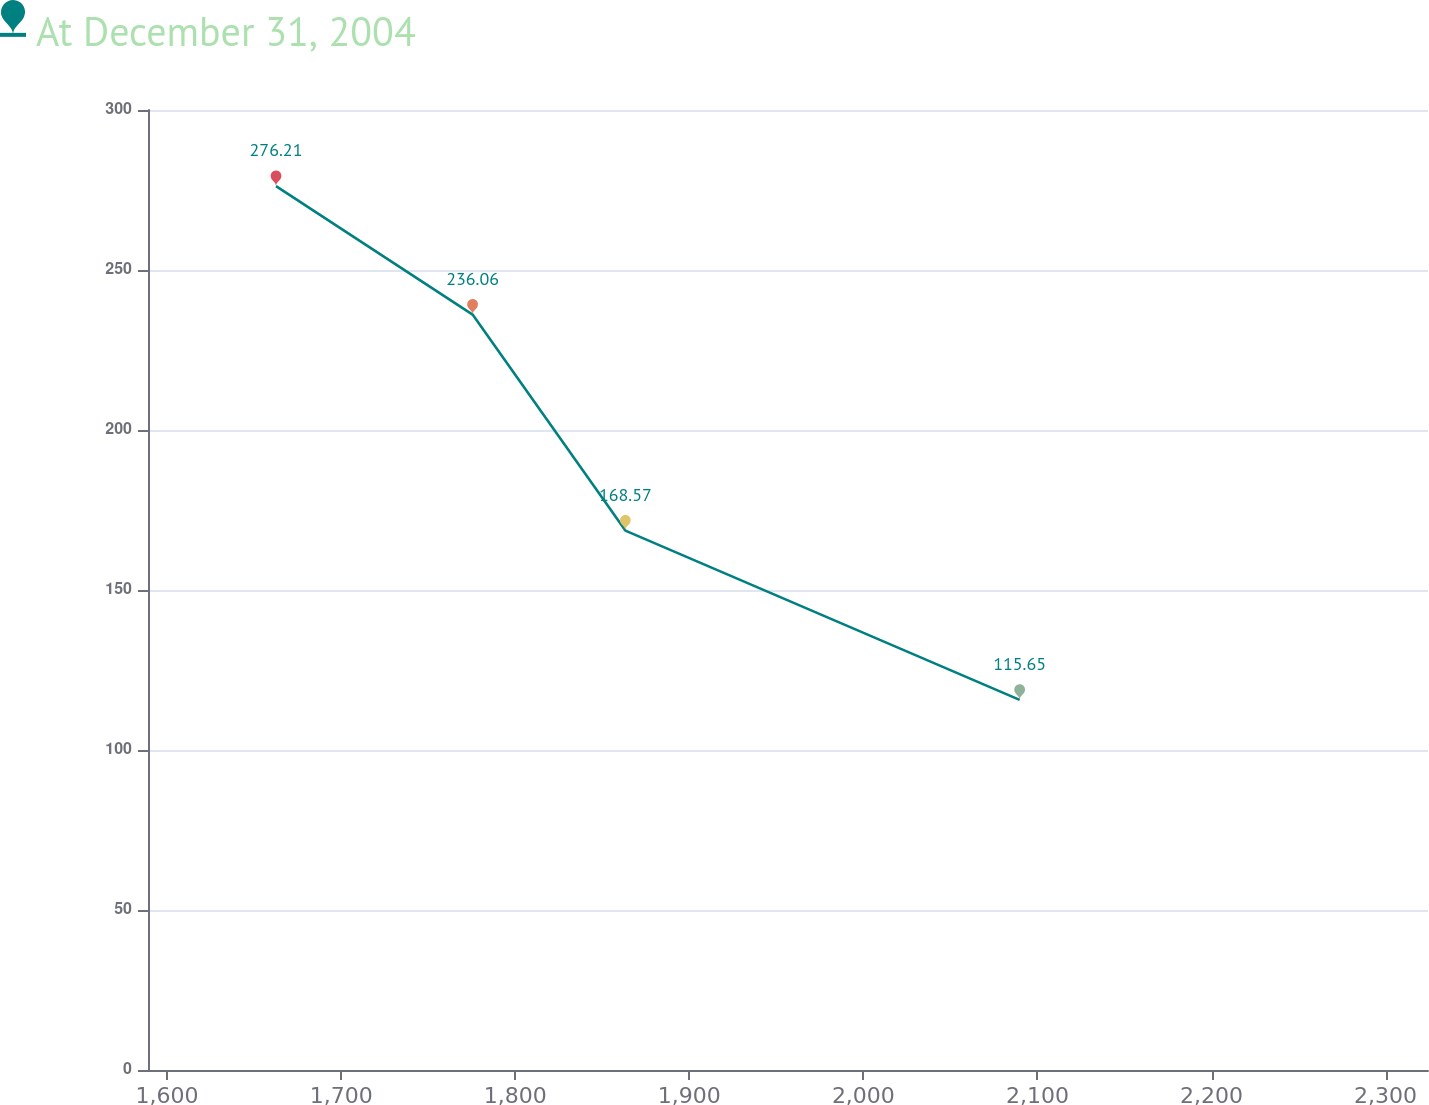<chart> <loc_0><loc_0><loc_500><loc_500><line_chart><ecel><fcel>At December 31, 2004<nl><fcel>1662.58<fcel>276.21<nl><fcel>1775.52<fcel>236.06<nl><fcel>1863.28<fcel>168.57<nl><fcel>2089.77<fcel>115.65<nl><fcel>2397.89<fcel>74.91<nl></chart> 